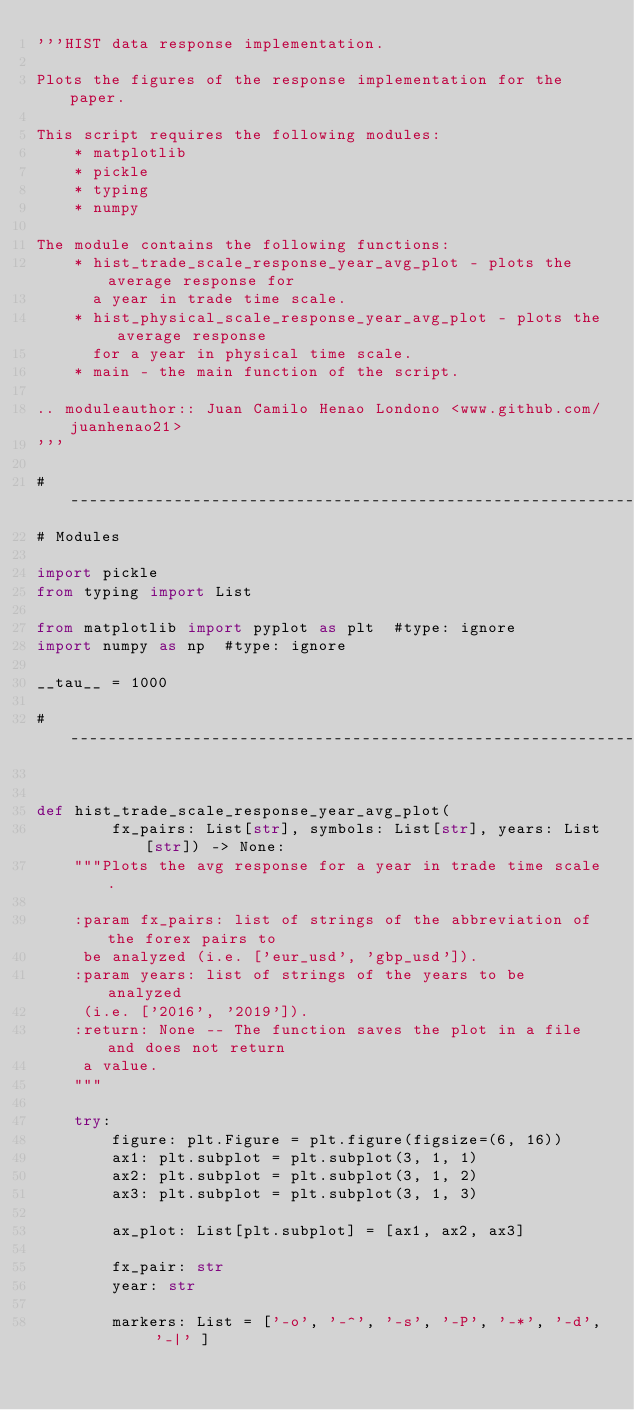<code> <loc_0><loc_0><loc_500><loc_500><_Python_>'''HIST data response implementation.

Plots the figures of the response implementation for the paper.

This script requires the following modules:
    * matplotlib
    * pickle
    * typing
    * numpy

The module contains the following functions:
    * hist_trade_scale_response_year_avg_plot - plots the average response for
      a year in trade time scale.
    * hist_physical_scale_response_year_avg_plot - plots the average response
      for a year in physical time scale.
    * main - the main function of the script.

.. moduleauthor:: Juan Camilo Henao Londono <www.github.com/juanhenao21>
'''

# ----------------------------------------------------------------------------
# Modules

import pickle
from typing import List

from matplotlib import pyplot as plt  #type: ignore
import numpy as np  #type: ignore

__tau__ = 1000

# ----------------------------------------------------------------------------


def hist_trade_scale_response_year_avg_plot(
        fx_pairs: List[str], symbols: List[str], years: List[str]) -> None:
    """Plots the avg response for a year in trade time scale.

    :param fx_pairs: list of strings of the abbreviation of the forex pairs to
     be analyzed (i.e. ['eur_usd', 'gbp_usd']).
    :param years: list of strings of the years to be analyzed
     (i.e. ['2016', '2019']).
    :return: None -- The function saves the plot in a file and does not return
     a value.
    """

    try:
        figure: plt.Figure = plt.figure(figsize=(6, 16))
        ax1: plt.subplot = plt.subplot(3, 1, 1)
        ax2: plt.subplot = plt.subplot(3, 1, 2)
        ax3: plt.subplot = plt.subplot(3, 1, 3)

        ax_plot: List[plt.subplot] = [ax1, ax2, ax3]

        fx_pair: str
        year: str

        markers: List = ['-o', '-^', '-s', '-P', '-*', '-d', '-|' ]
</code> 